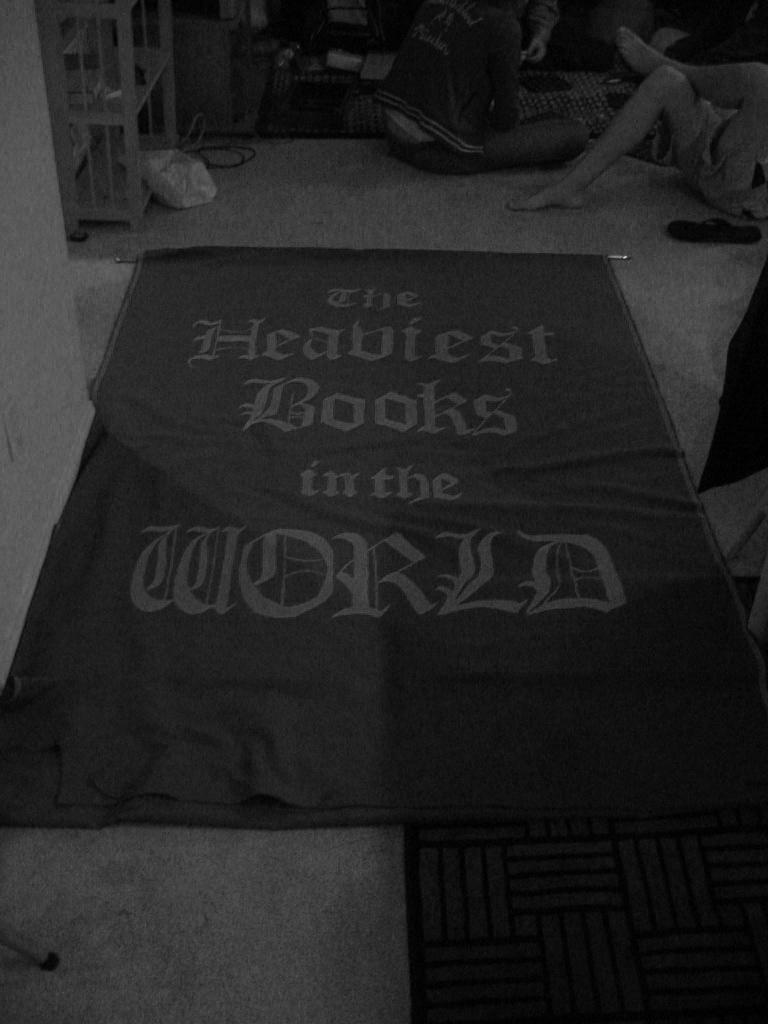What is located in the foreground of the image? There is a mat and a banner with text in the foreground of the image. What can be seen at the top of the image? There are people and objects visible at the top of the image, as well as a rack. What might the banner with text be used for in the image? The banner with text might be used for conveying information or advertising in the image. Can you see a guitar being played by someone in the image? There is no guitar visible in the image. Is there a cellar visible in the image? There is no mention of a cellar in the provided facts, and therefore it cannot be confirmed or denied. 